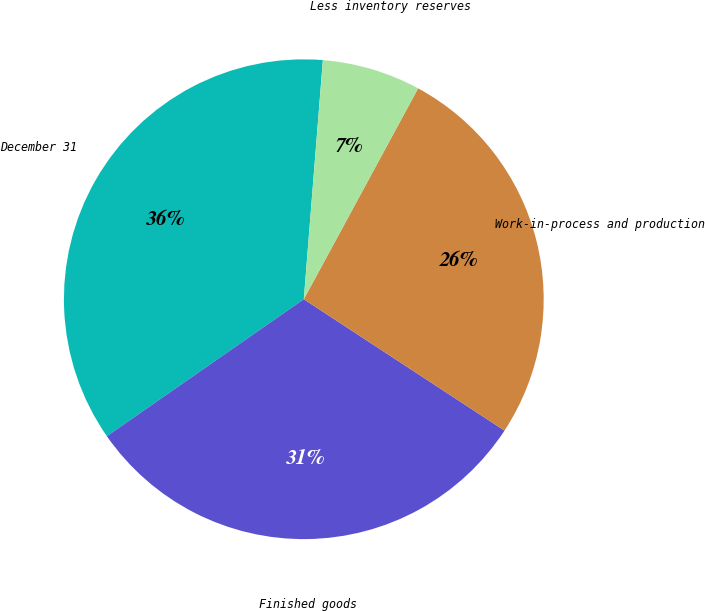Convert chart to OTSL. <chart><loc_0><loc_0><loc_500><loc_500><pie_chart><fcel>December 31<fcel>Finished goods<fcel>Work-in-process and production<fcel>Less inventory reserves<nl><fcel>35.94%<fcel>31.1%<fcel>26.32%<fcel>6.64%<nl></chart> 